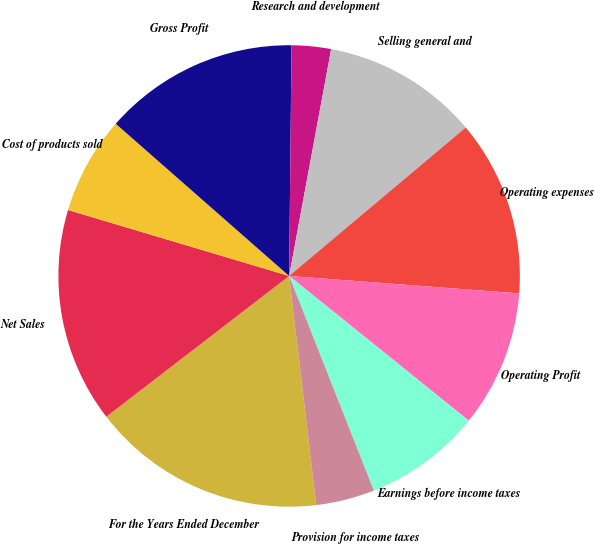<chart> <loc_0><loc_0><loc_500><loc_500><pie_chart><fcel>For the Years Ended December<fcel>Net Sales<fcel>Cost of products sold<fcel>Gross Profit<fcel>Research and development<fcel>Selling general and<fcel>Operating expenses<fcel>Operating Profit<fcel>Earnings before income taxes<fcel>Provision for income taxes<nl><fcel>16.43%<fcel>15.06%<fcel>6.85%<fcel>13.7%<fcel>2.75%<fcel>10.96%<fcel>12.33%<fcel>9.59%<fcel>8.22%<fcel>4.11%<nl></chart> 